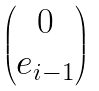<formula> <loc_0><loc_0><loc_500><loc_500>\begin{pmatrix} 0 \\ e _ { i - 1 } \end{pmatrix}</formula> 